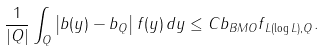Convert formula to latex. <formula><loc_0><loc_0><loc_500><loc_500>\frac { 1 } { | Q | } \int _ { Q } \left | b ( y ) - b _ { Q } \right | f ( y ) \, d y \leq C \| b \| _ { B M O } \| f \| _ { L ( \log L ) , Q } .</formula> 